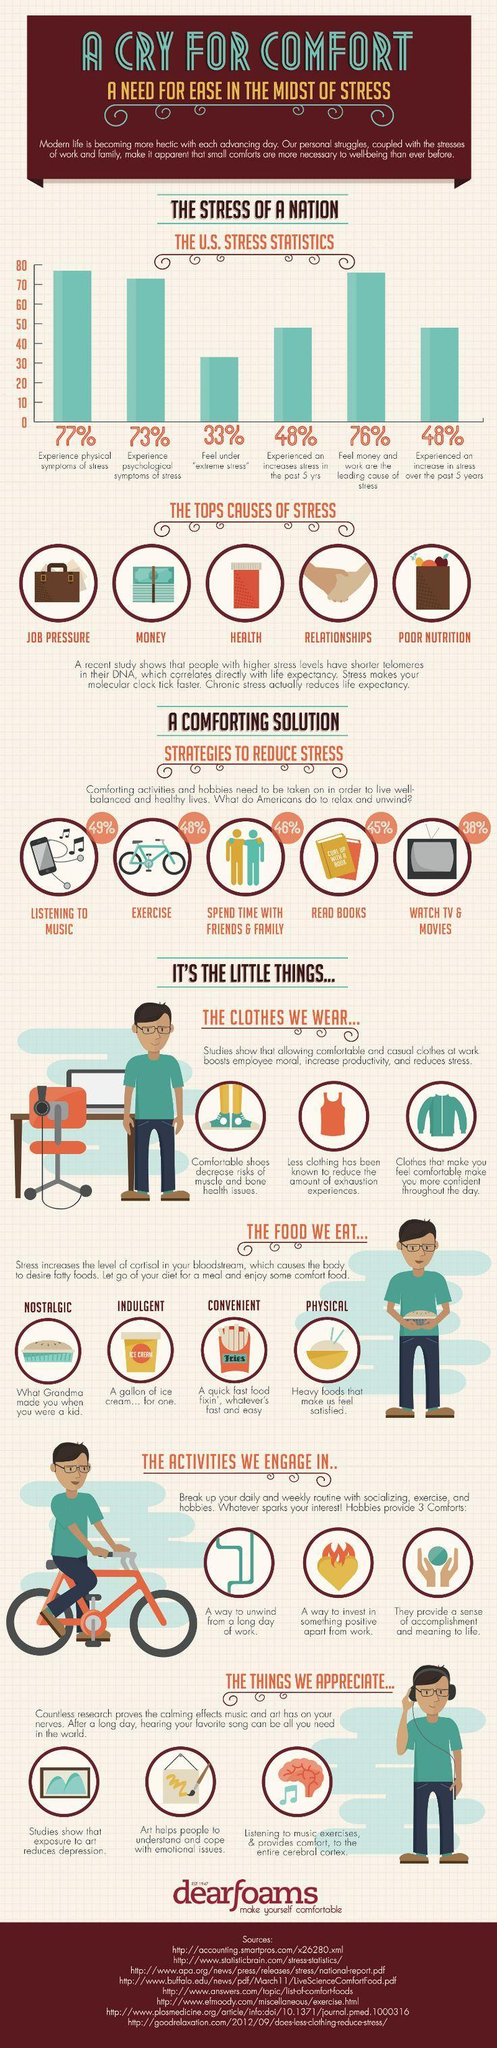What is the reason to desire fatty foods?
Answer the question with a short phrase. level of cortisol Which activity helps you to reduce stress the most? LISTENING TO MUSIC How many types of food have been listed? 4 